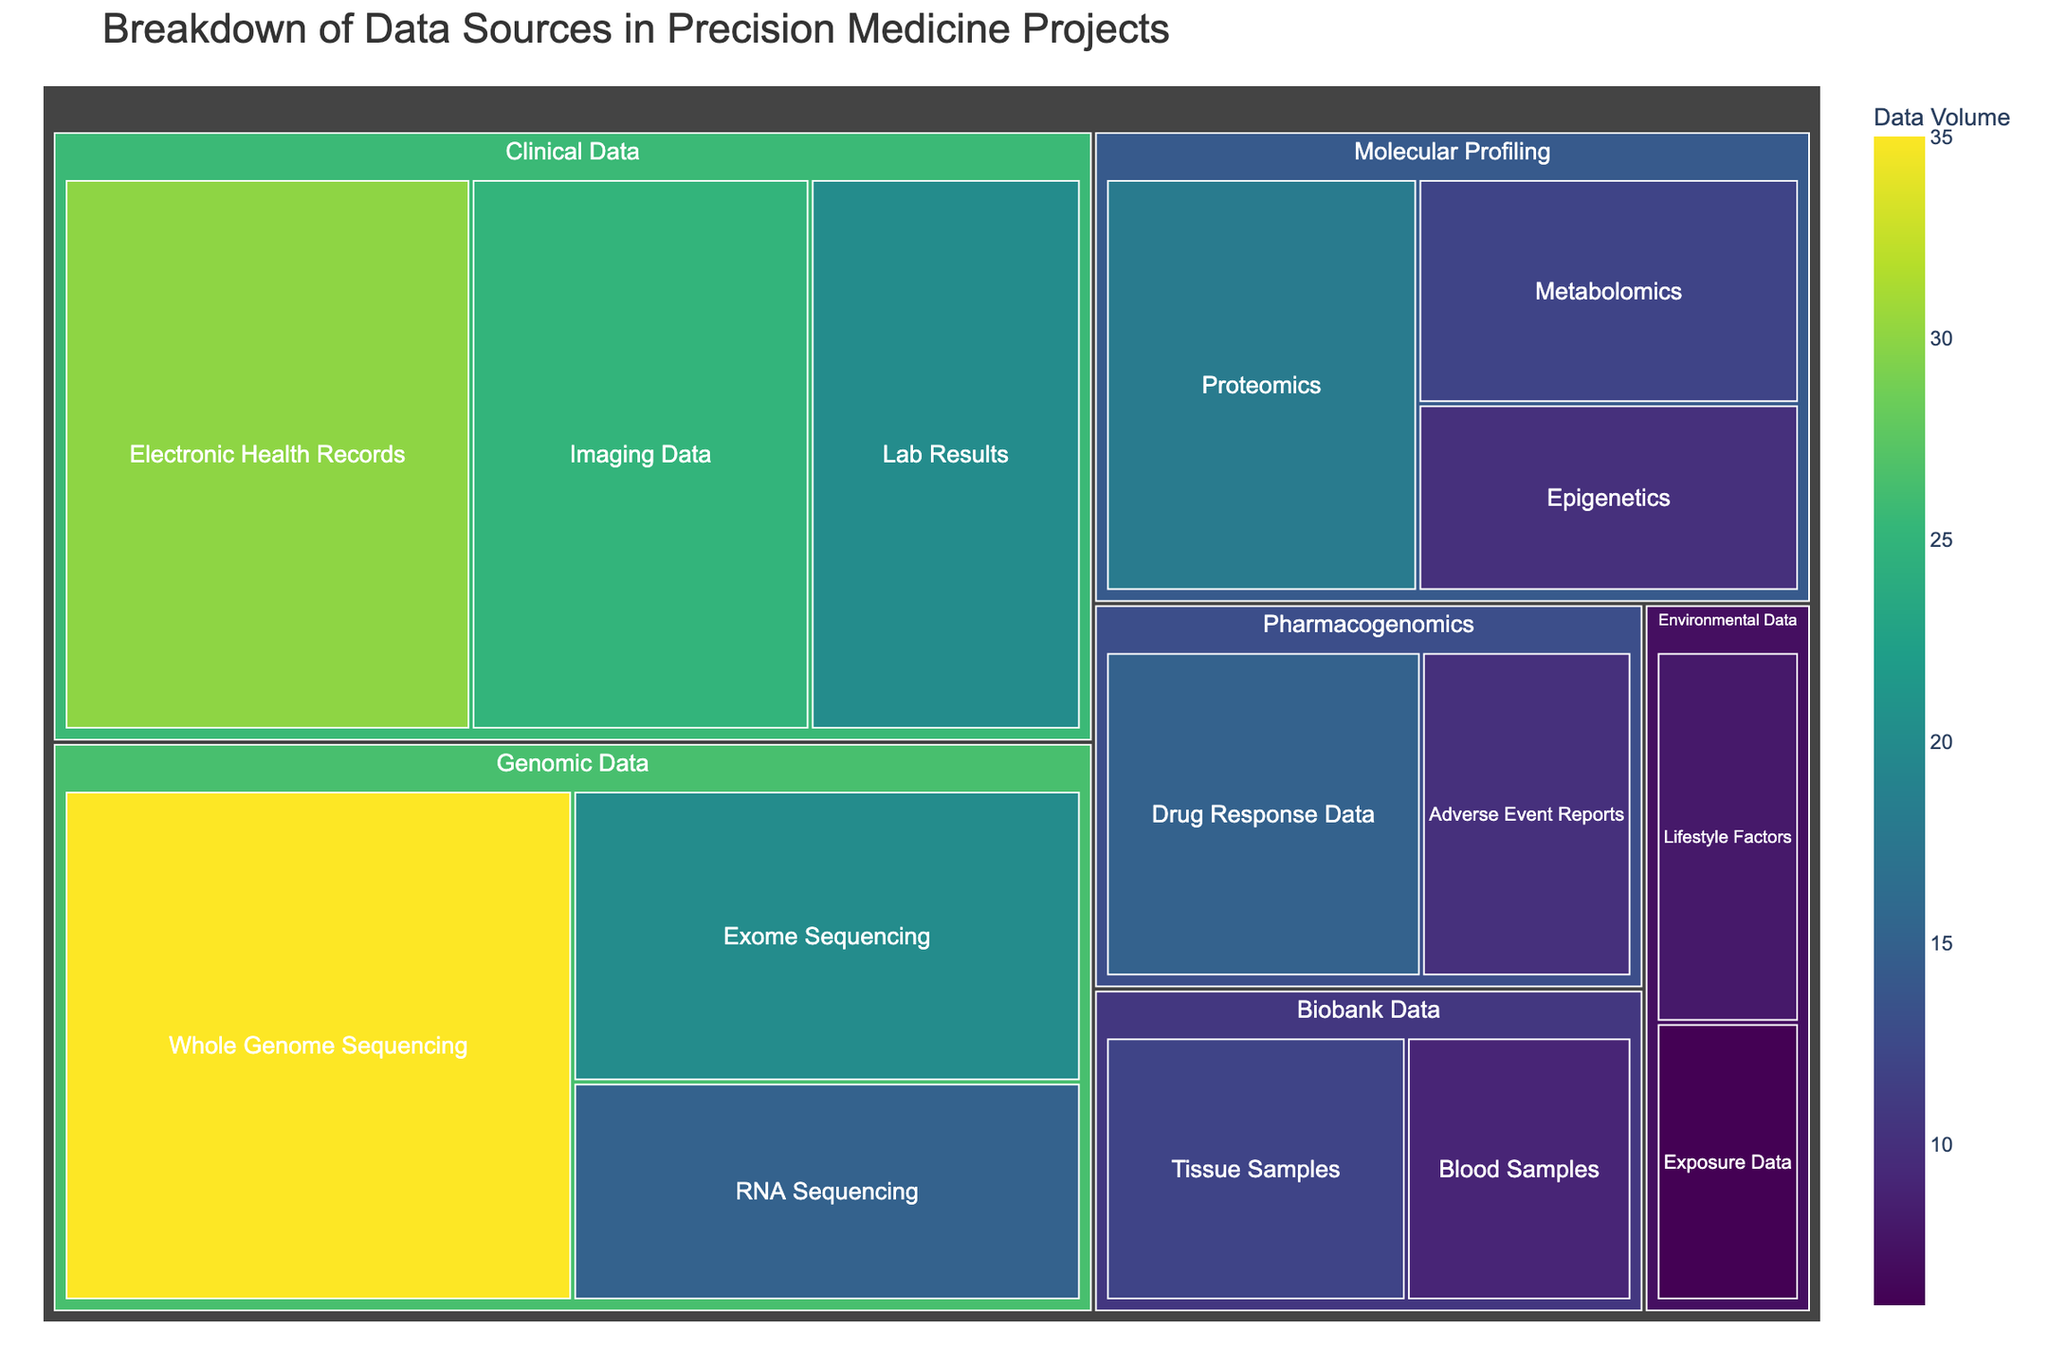What's the total volume of genomic data? The volume for each genomic data subcategory is: Whole Genome Sequencing (35), Exome Sequencing (20), and RNA Sequencing (15). Sum these values to get the total: 35 + 20 + 15.
Answer: 70 Which subcategory has the highest volume? Identify the subcategory with the maximum size value. In this case, it’s Whole Genome Sequencing with a size of 35.
Answer: Whole Genome Sequencing How does the volume of clinical data compare to genomic data? The total volume of clinical data is the sum of its subcategories: Electronic Health Records (30), Imaging Data (25), and Lab Results (20). The total is 30 + 25 + 20 = 75. The total genomic data volume is 70. Compare these totals: 75 vs. 70.
Answer: Clinical data has a higher volume What's the combined volume of Pharmacogenomics and Biobank Data? The volume for Pharmacogenomics is: Drug Response Data (15) + Adverse Event Reports (10) = 25. The volume for Biobank Data is: Tissue Samples (12) + Blood Samples (9) = 21. Sum these: 25 + 21.
Answer: 46 Which category has the smallest total volume? Calculate the total volume for each category and compare them. The smallest totals are Environmental Data (8 + 6 = 14) and Molecular Profiling (18 + 12 + 10 = 40). The smallest of these is Environmental Data.
Answer: Environmental Data What is the percentage of RNA Sequencing within Genomic Data? RNA Sequencing volume (15) divided by total Genomic Data volume (70) times 100: (15/70) * 100.
Answer: ~21.43% Which category has more subcategories: Molecular Profiling or Pharmacogenomics? Count the number of subcategories in each. Molecular Profiling has 3 (Proteomics, Metabolomics, Epigenetics); Pharmacogenomics has 2 (Drug Response Data, Adverse Event Reports).
Answer: Molecular Profiling What's the difference in volume between Imaging Data and Lifestyle Factors? The volume of Imaging Data is 25. The volume of Lifestyle Factors is 8. Subtract these: 25 - 8.
Answer: 17 Which category uses the widest range of data source subtypes? Identify which category has the highest number of subcategories. Genomic Data has 3 subcategories, Clinical Data has 3, Molecular Profiling has 3, and others have fewer.
Answer: Genomic Data, Clinical Data, Molecular Profiling What proportion of the total data volume does Electronic Health Records represent? Calculate the sum of all data volumes and then the proportion of Electronic Health Records. Total data volume is 35+20+15+30+25+20+18+12+10+8+6+15+10+12+9=245. Proportion is (30/245)*100.
Answer: ~12.24% 